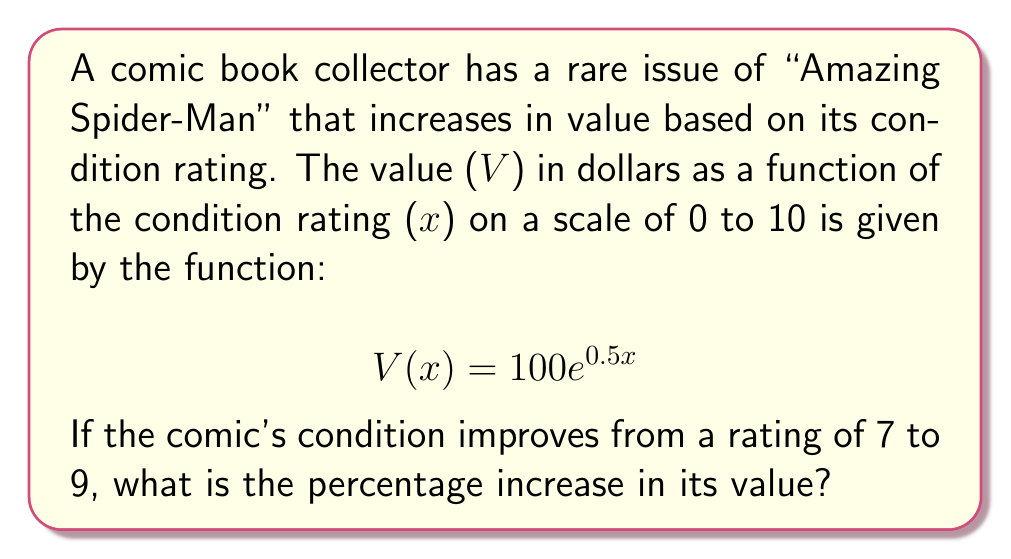Solve this math problem. To solve this problem, we'll follow these steps:

1) Calculate the value at x = 7:
   $$V(7) = 100e^{0.5(7)} = 100e^{3.5}$$

2) Calculate the value at x = 9:
   $$V(9) = 100e^{0.5(9)} = 100e^{4.5}$$

3) Calculate the difference in value:
   $$\text{Difference} = V(9) - V(7) = 100e^{4.5} - 100e^{3.5}$$

4) Calculate the percentage increase:
   $$\text{Percentage Increase} = \frac{\text{Difference}}{V(7)} \times 100\%$$
   
   $$= \frac{100e^{4.5} - 100e^{3.5}}{100e^{3.5}} \times 100\%$$
   
   $$= \frac{e^{4.5} - e^{3.5}}{e^{3.5}} \times 100\%$$
   
   $$= (e^1 - 1) \times 100\%$$
   
   $$= (e - 1) \times 100\%$$
   
   $$\approx 171.83\%$$

Therefore, the percentage increase in the comic's value when its condition improves from 7 to 9 is approximately 171.83%.
Answer: 171.83% 